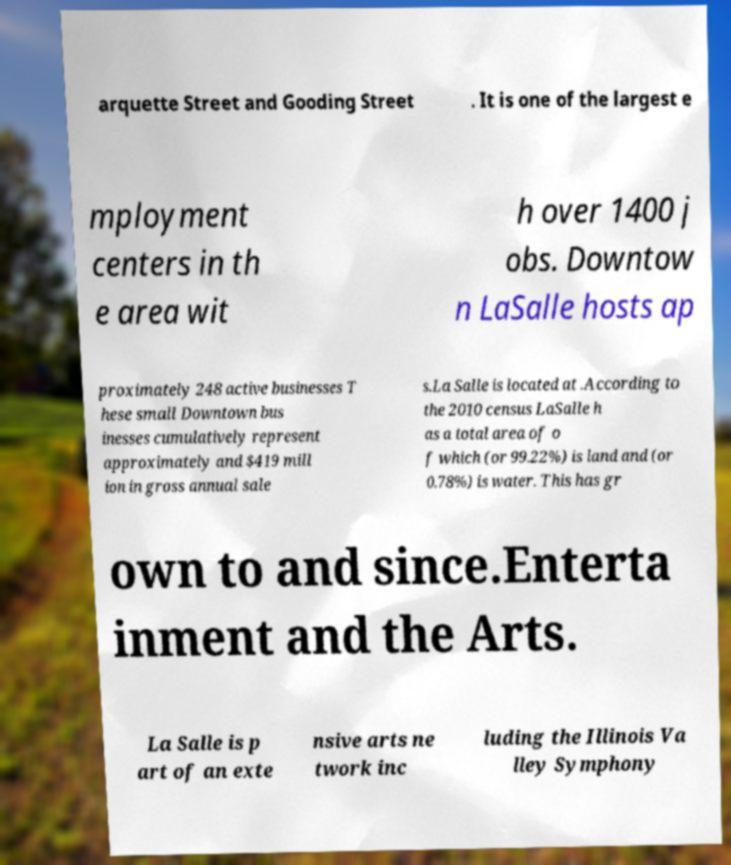Can you read and provide the text displayed in the image?This photo seems to have some interesting text. Can you extract and type it out for me? arquette Street and Gooding Street . It is one of the largest e mployment centers in th e area wit h over 1400 j obs. Downtow n LaSalle hosts ap proximately 248 active businesses T hese small Downtown bus inesses cumulatively represent approximately and $419 mill ion in gross annual sale s.La Salle is located at .According to the 2010 census LaSalle h as a total area of o f which (or 99.22%) is land and (or 0.78%) is water. This has gr own to and since.Enterta inment and the Arts. La Salle is p art of an exte nsive arts ne twork inc luding the Illinois Va lley Symphony 